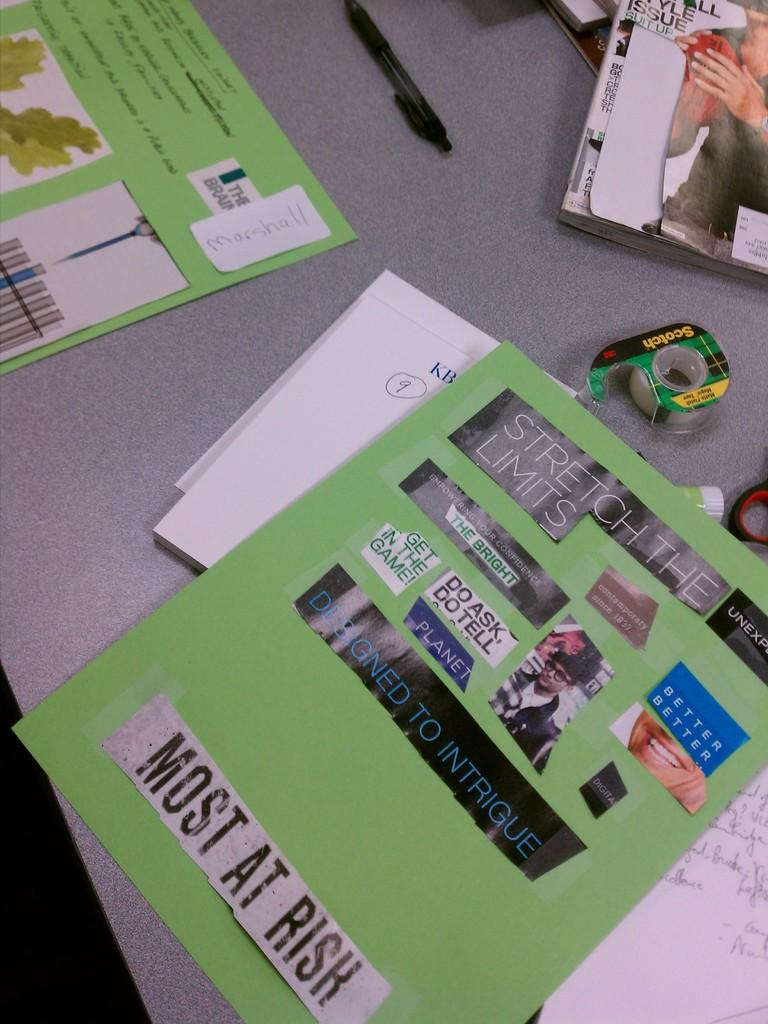Provide a one-sentence caption for the provided image. Several work projects, a magazine, pen and some Scotch tape sitting on a table. 